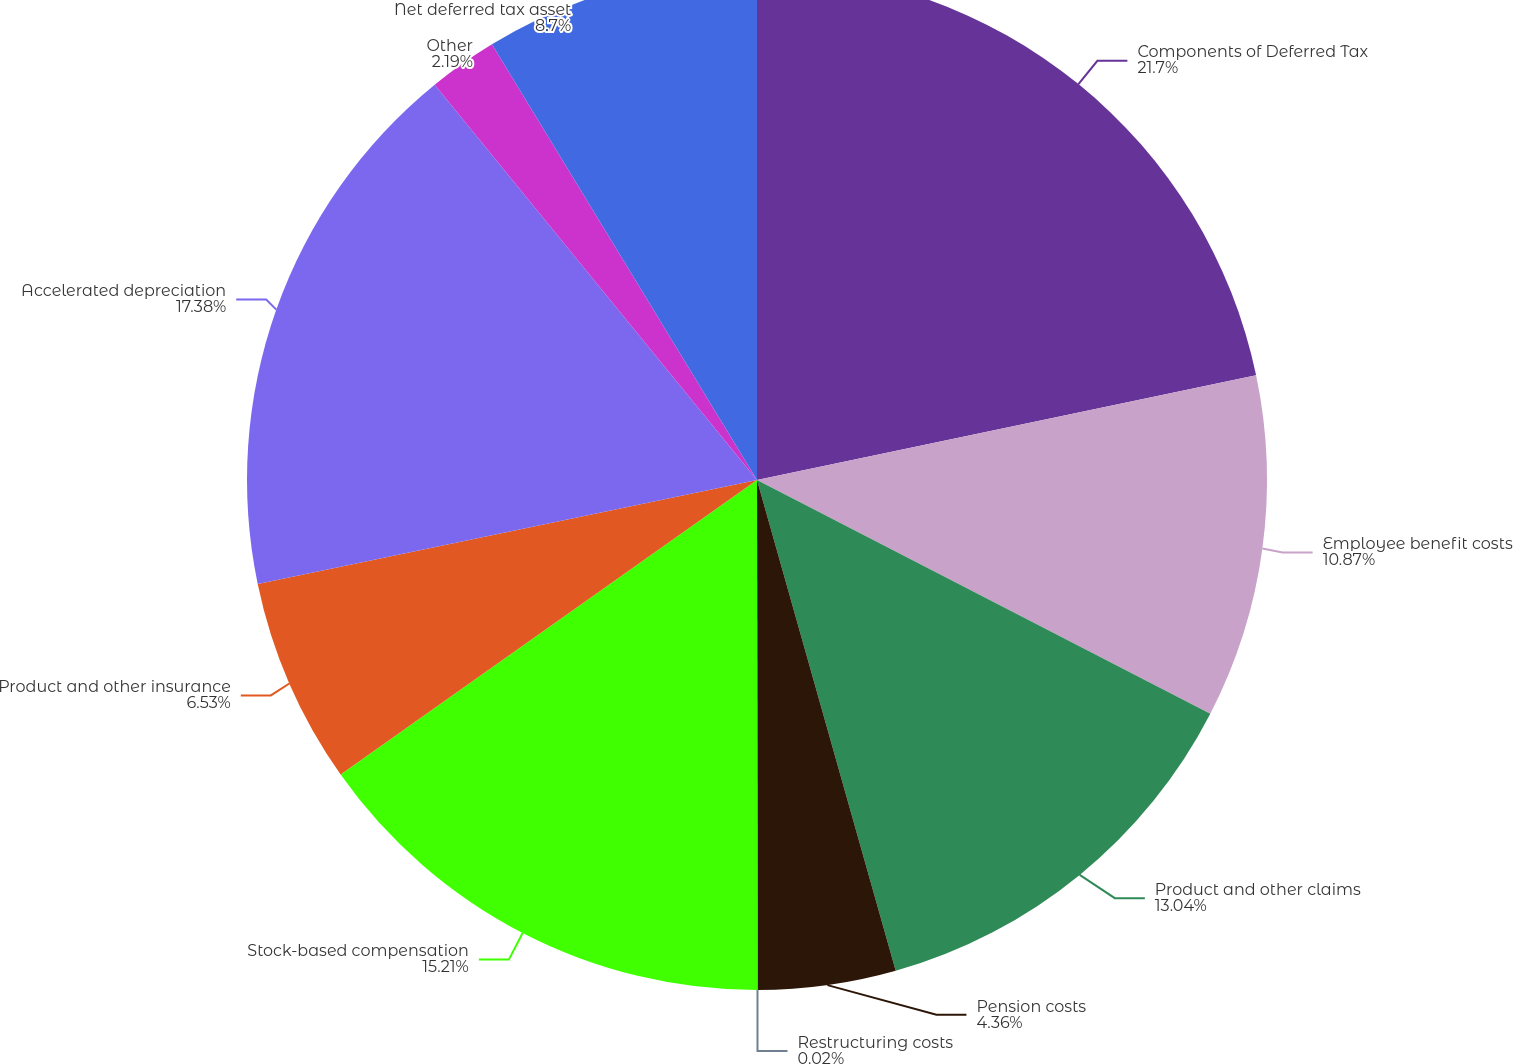<chart> <loc_0><loc_0><loc_500><loc_500><pie_chart><fcel>Components of Deferred Tax<fcel>Employee benefit costs<fcel>Product and other claims<fcel>Pension costs<fcel>Restructuring costs<fcel>Stock-based compensation<fcel>Product and other insurance<fcel>Accelerated depreciation<fcel>Other<fcel>Net deferred tax asset<nl><fcel>21.71%<fcel>10.87%<fcel>13.04%<fcel>4.36%<fcel>0.02%<fcel>15.21%<fcel>6.53%<fcel>17.38%<fcel>2.19%<fcel>8.7%<nl></chart> 